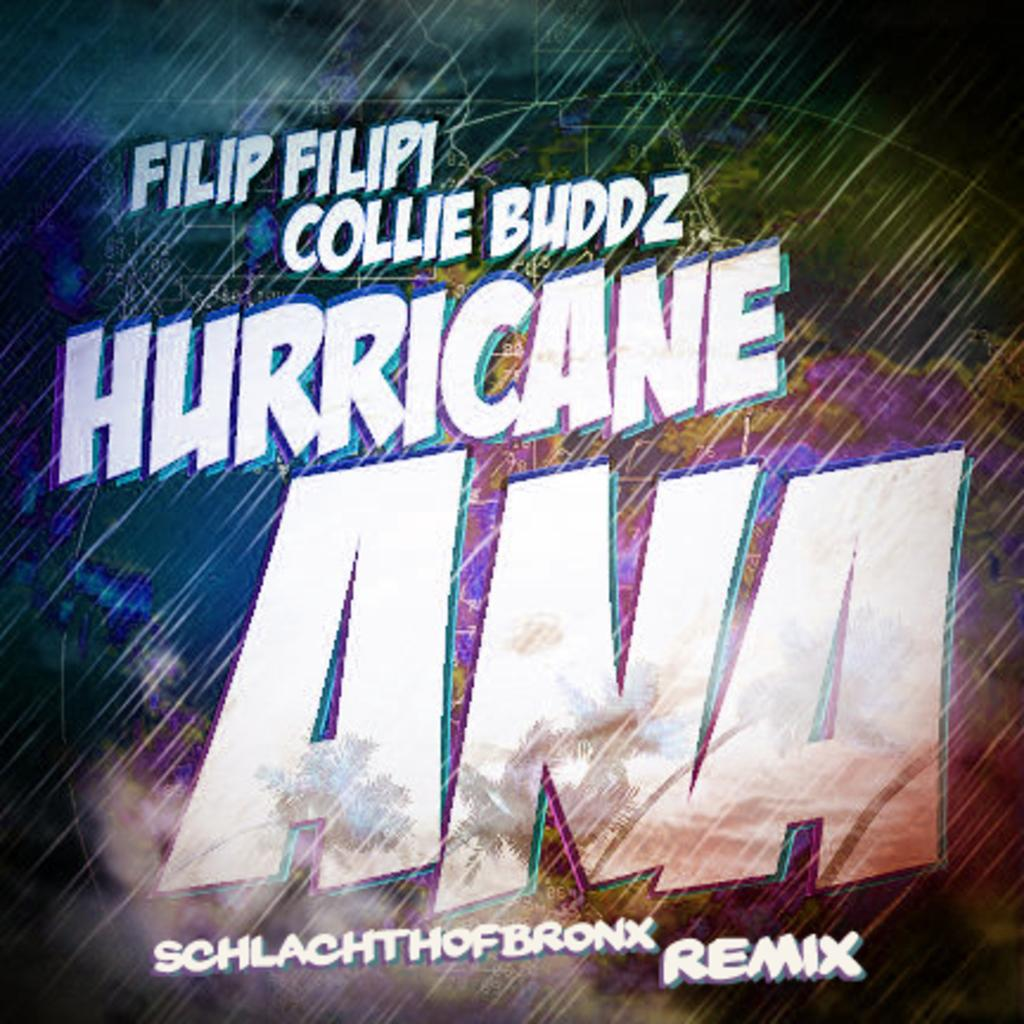<image>
Give a short and clear explanation of the subsequent image. A weather map featuring falling rain album cover art for Schlachth Of Bronx remix. 